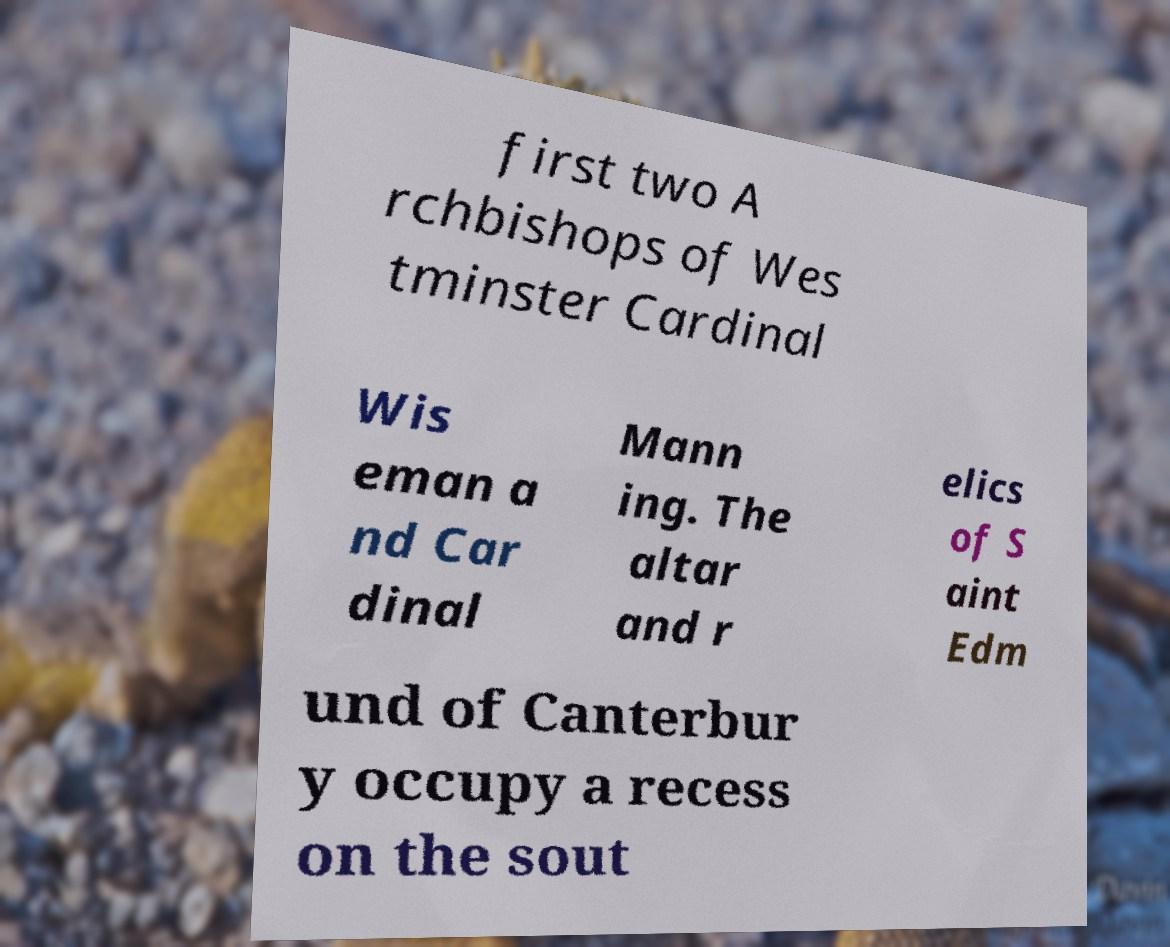I need the written content from this picture converted into text. Can you do that? first two A rchbishops of Wes tminster Cardinal Wis eman a nd Car dinal Mann ing. The altar and r elics of S aint Edm und of Canterbur y occupy a recess on the sout 